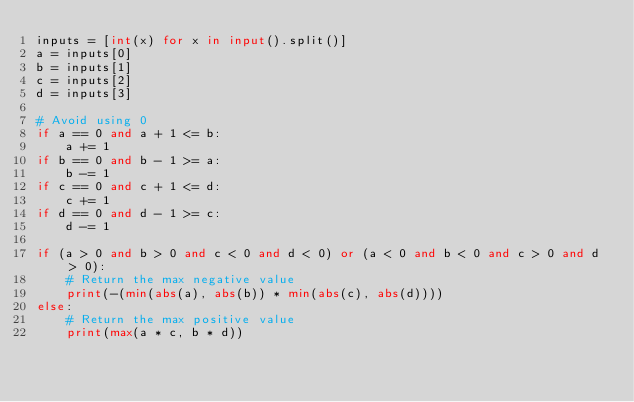Convert code to text. <code><loc_0><loc_0><loc_500><loc_500><_Python_>inputs = [int(x) for x in input().split()]
a = inputs[0]
b = inputs[1]
c = inputs[2]
d = inputs[3]

# Avoid using 0
if a == 0 and a + 1 <= b:
    a += 1
if b == 0 and b - 1 >= a:
    b -= 1
if c == 0 and c + 1 <= d:
    c += 1
if d == 0 and d - 1 >= c:
    d -= 1

if (a > 0 and b > 0 and c < 0 and d < 0) or (a < 0 and b < 0 and c > 0 and d > 0):
    # Return the max negative value
    print(-(min(abs(a), abs(b)) * min(abs(c), abs(d))))    
else:
    # Return the max positive value
    print(max(a * c, b * d))</code> 